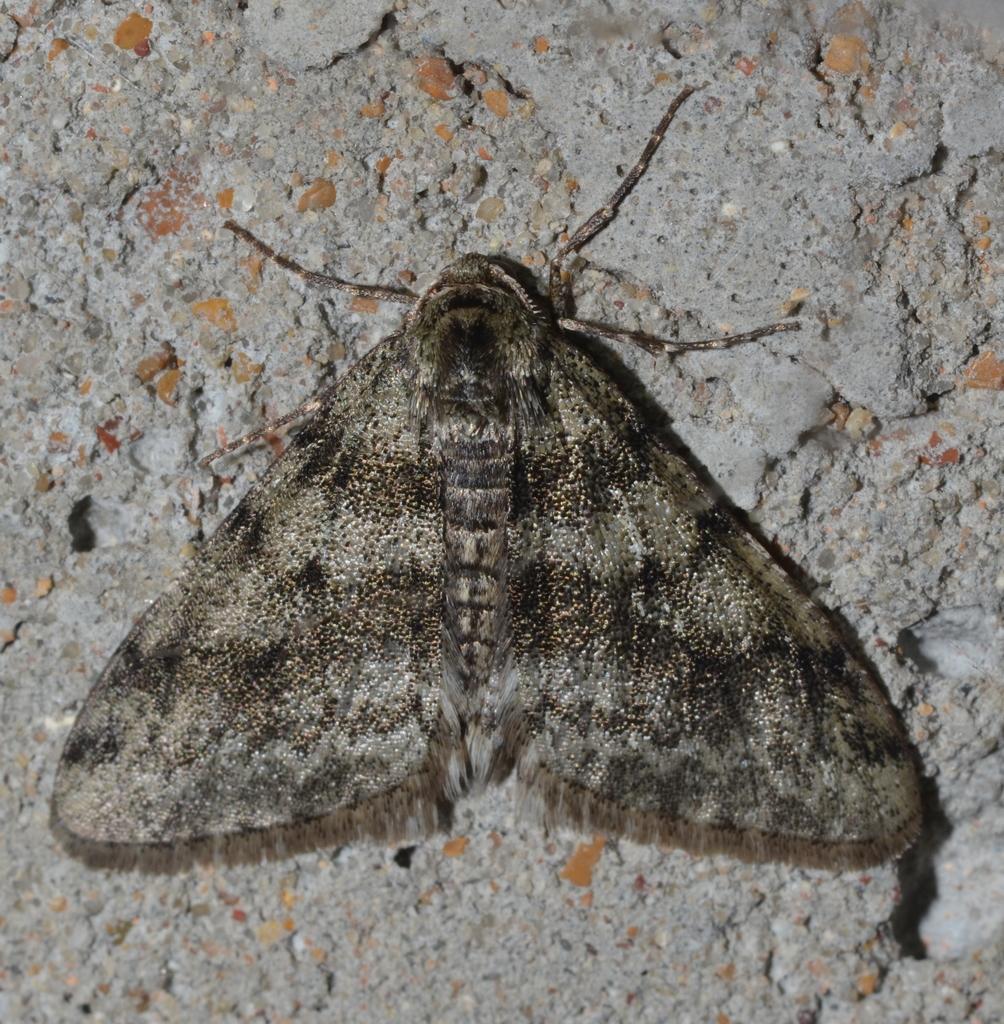How would you summarize this image in a sentence or two? In this image we can see an insect on the surface and the surface looks like a cement base. 